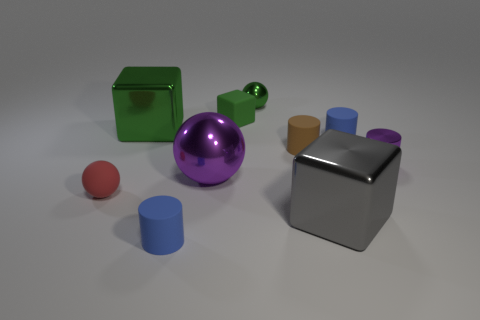Is the color of the tiny metallic object that is in front of the small brown cylinder the same as the metal ball in front of the large green thing? yes 